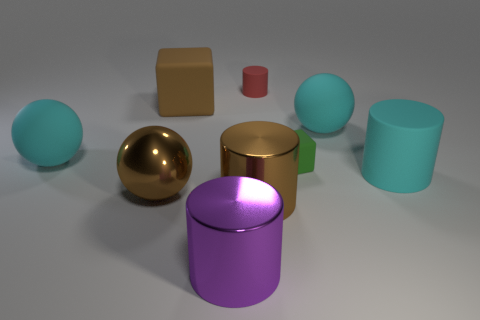What number of other objects are the same size as the green matte object?
Make the answer very short. 1. There is a cyan object left of the small cylinder; what is it made of?
Offer a terse response. Rubber. There is a big cyan thing to the right of the cyan rubber ball on the right side of the rubber ball that is on the left side of the tiny red matte object; what shape is it?
Provide a succinct answer. Cylinder. Do the red rubber thing and the shiny sphere have the same size?
Offer a terse response. No. How many things are either purple metal balls or large brown metallic things on the left side of the brown rubber thing?
Ensure brevity in your answer.  1. How many things are either large rubber spheres to the right of the purple metal cylinder or big cyan objects that are on the left side of the large metal sphere?
Ensure brevity in your answer.  2. Are there any purple metal things on the left side of the brown matte block?
Provide a short and direct response. No. What is the color of the matte block in front of the big brown thing behind the large matte ball on the left side of the big metallic sphere?
Keep it short and to the point. Green. Is the small red object the same shape as the brown matte object?
Provide a succinct answer. No. The tiny block that is the same material as the big brown block is what color?
Make the answer very short. Green. 